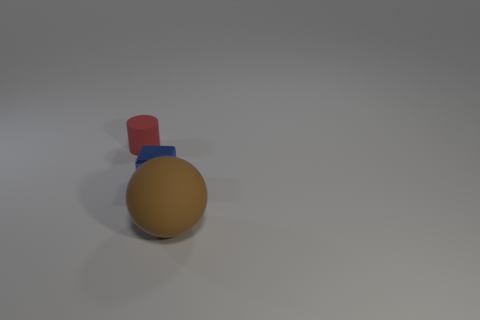Add 3 small purple metal blocks. How many objects exist? 6 Add 1 big brown things. How many big brown things are left? 2 Add 3 red matte objects. How many red matte objects exist? 4 Subtract 1 blue cubes. How many objects are left? 2 Subtract all cylinders. How many objects are left? 2 Subtract all balls. Subtract all small red rubber cylinders. How many objects are left? 1 